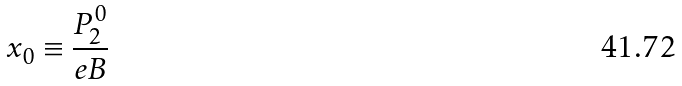Convert formula to latex. <formula><loc_0><loc_0><loc_500><loc_500>x _ { 0 } \equiv \frac { P _ { 2 } ^ { 0 } } { e B }</formula> 